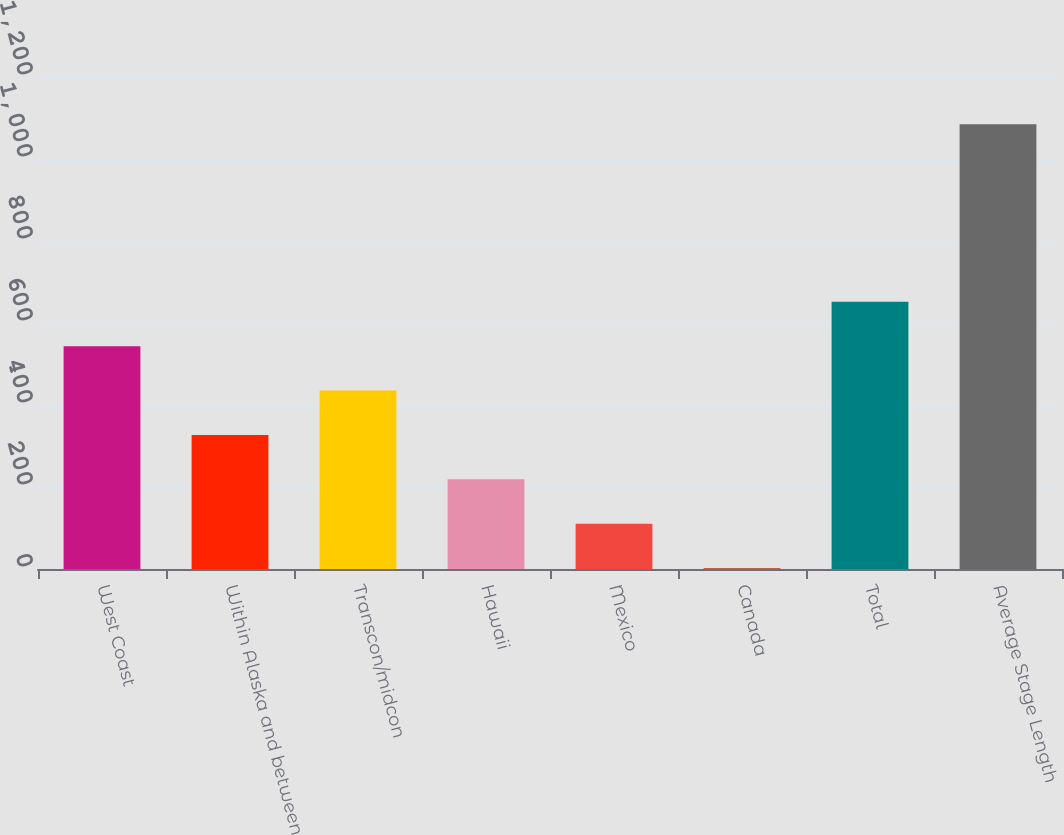Convert chart to OTSL. <chart><loc_0><loc_0><loc_500><loc_500><bar_chart><fcel>West Coast<fcel>Within Alaska and between<fcel>Transcon/midcon<fcel>Hawaii<fcel>Mexico<fcel>Canada<fcel>Total<fcel>Average Stage Length<nl><fcel>543.5<fcel>326.9<fcel>435.2<fcel>218.6<fcel>110.3<fcel>2<fcel>651.8<fcel>1085<nl></chart> 